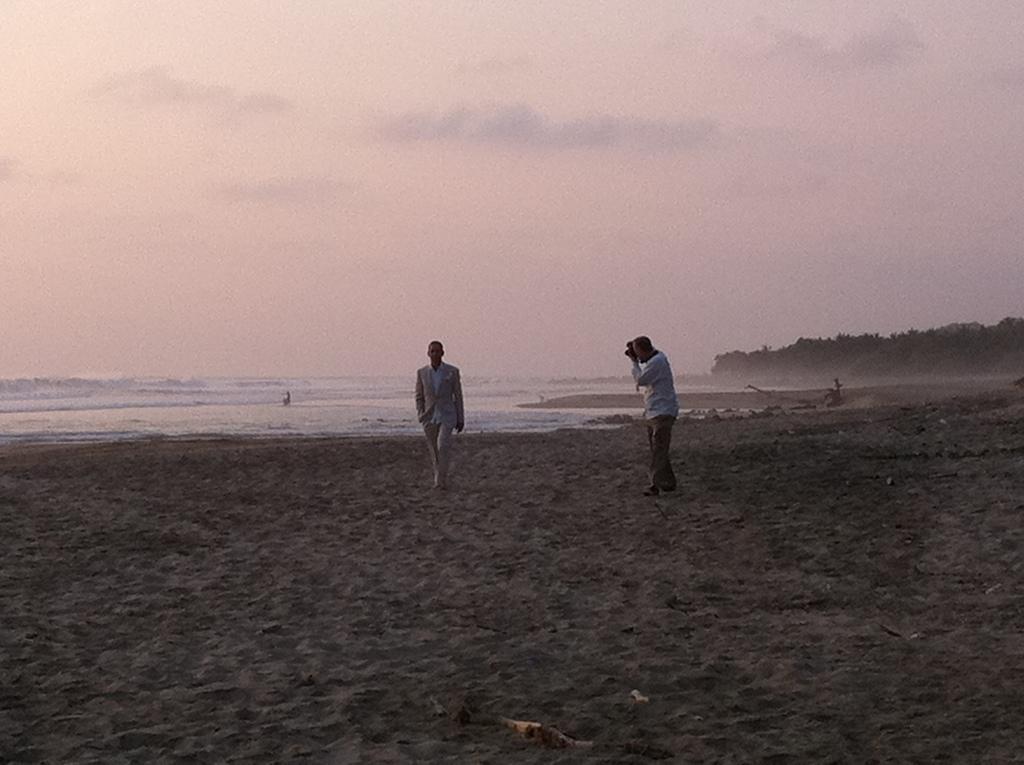Could you give a brief overview of what you see in this image? The image is taken at the beach. In the center of the image we can see a man walking. He is wearing a suit. On the right there is another man standing and holding a camera. In the background there is a sea and sky. On the right there are trees. 